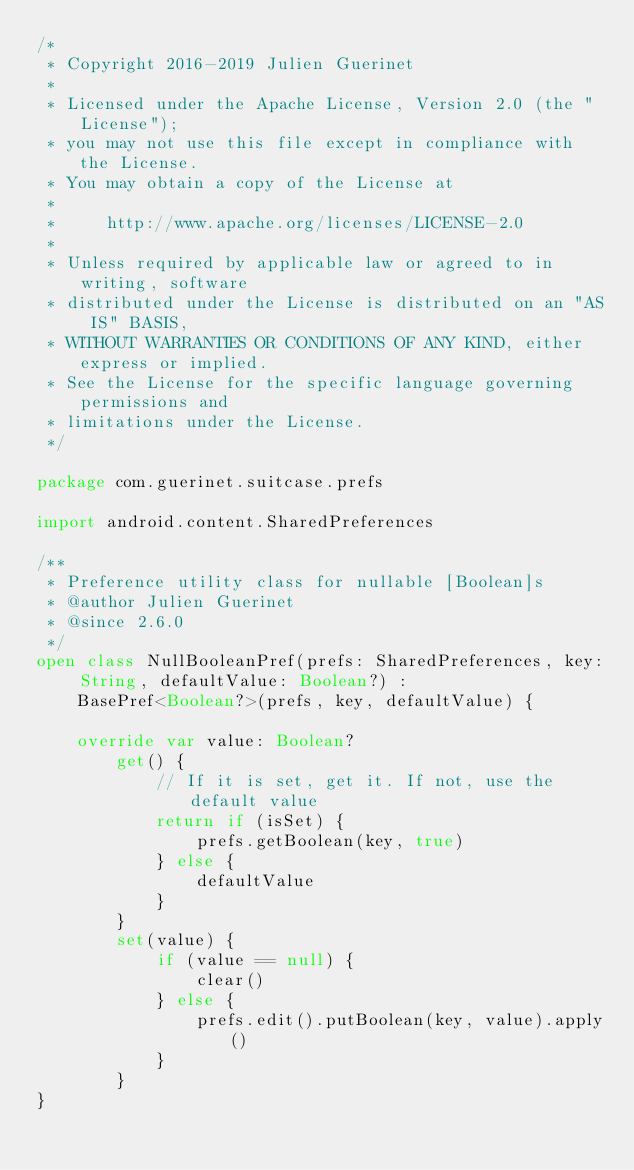Convert code to text. <code><loc_0><loc_0><loc_500><loc_500><_Kotlin_>/*
 * Copyright 2016-2019 Julien Guerinet
 *
 * Licensed under the Apache License, Version 2.0 (the "License");
 * you may not use this file except in compliance with the License.
 * You may obtain a copy of the License at
 *
 *     http://www.apache.org/licenses/LICENSE-2.0
 *
 * Unless required by applicable law or agreed to in writing, software
 * distributed under the License is distributed on an "AS IS" BASIS,
 * WITHOUT WARRANTIES OR CONDITIONS OF ANY KIND, either express or implied.
 * See the License for the specific language governing permissions and
 * limitations under the License.
 */

package com.guerinet.suitcase.prefs

import android.content.SharedPreferences

/**
 * Preference utility class for nullable [Boolean]s
 * @author Julien Guerinet
 * @since 2.6.0
 */
open class NullBooleanPref(prefs: SharedPreferences, key: String, defaultValue: Boolean?) :
    BasePref<Boolean?>(prefs, key, defaultValue) {

    override var value: Boolean?
        get() {
            // If it is set, get it. If not, use the default value
            return if (isSet) {
                prefs.getBoolean(key, true)
            } else {
                defaultValue
            }
        }
        set(value) {
            if (value == null) {
                clear()
            } else {
                prefs.edit().putBoolean(key, value).apply()
            }
        }
}
</code> 